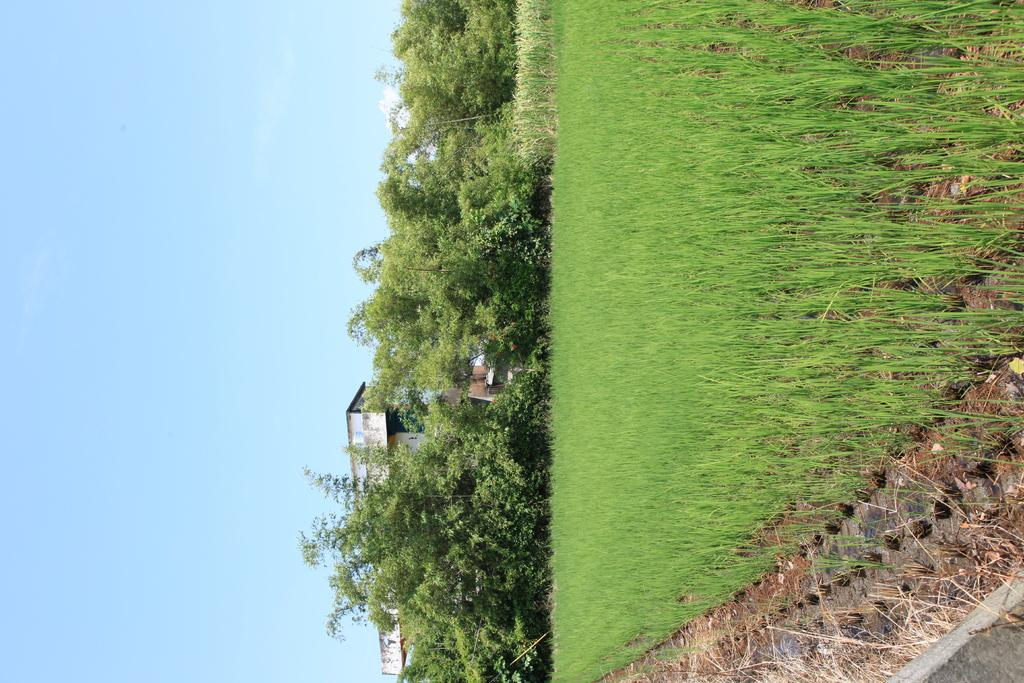How is the image oriented? The image is tilted. What can be seen in the background of the image? There is a building visible in the background. What part of the natural environment is visible in the image? The sky, trees, and plants are visible in the image. What type of landscape is present in the image? There is a field in the image. What type of advice is the minister giving to the father in the image? There is no father or minister present in the image; it features a tilted image of a landscape with a building, sky, trees, plants, and a field. 